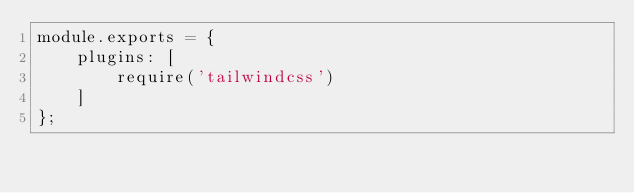<code> <loc_0><loc_0><loc_500><loc_500><_JavaScript_>module.exports = {
    plugins: [
        require('tailwindcss')
    ]
};
</code> 